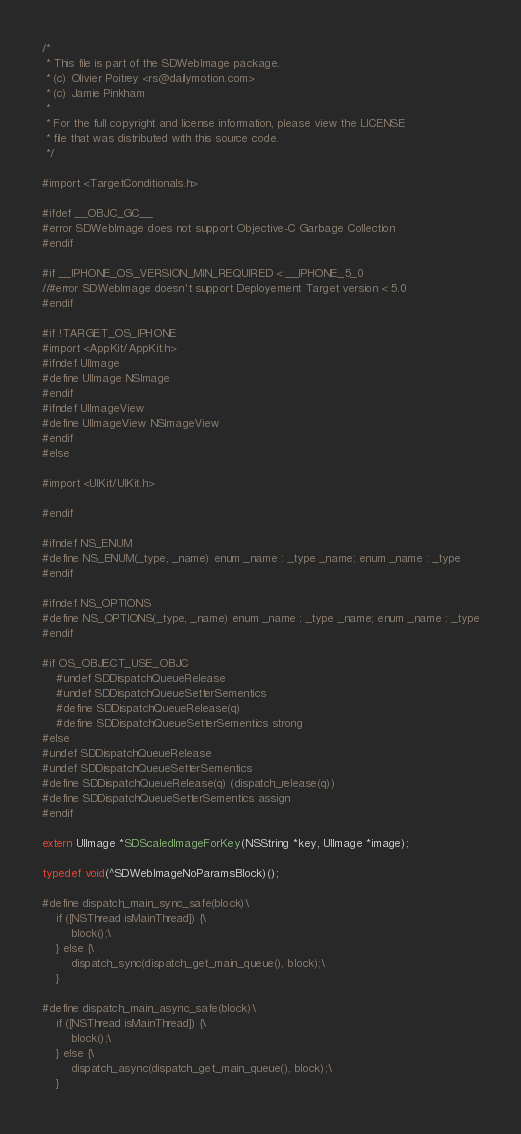<code> <loc_0><loc_0><loc_500><loc_500><_C_>/*
 * This file is part of the SDWebImage package.
 * (c) Olivier Poitrey <rs@dailymotion.com>
 * (c) Jamie Pinkham
 *
 * For the full copyright and license information, please view the LICENSE
 * file that was distributed with this source code.
 */

#import <TargetConditionals.h>

#ifdef __OBJC_GC__
#error SDWebImage does not support Objective-C Garbage Collection
#endif

#if __IPHONE_OS_VERSION_MIN_REQUIRED < __IPHONE_5_0
//#error SDWebImage doesn't support Deployement Target version < 5.0
#endif

#if !TARGET_OS_IPHONE
#import <AppKit/AppKit.h>
#ifndef UIImage
#define UIImage NSImage
#endif
#ifndef UIImageView
#define UIImageView NSImageView
#endif
#else

#import <UIKit/UIKit.h>

#endif

#ifndef NS_ENUM
#define NS_ENUM(_type, _name) enum _name : _type _name; enum _name : _type
#endif

#ifndef NS_OPTIONS
#define NS_OPTIONS(_type, _name) enum _name : _type _name; enum _name : _type
#endif

#if OS_OBJECT_USE_OBJC
    #undef SDDispatchQueueRelease
    #undef SDDispatchQueueSetterSementics
    #define SDDispatchQueueRelease(q)
    #define SDDispatchQueueSetterSementics strong
#else
#undef SDDispatchQueueRelease
#undef SDDispatchQueueSetterSementics
#define SDDispatchQueueRelease(q) (dispatch_release(q))
#define SDDispatchQueueSetterSementics assign
#endif

extern UIImage *SDScaledImageForKey(NSString *key, UIImage *image);

typedef void(^SDWebImageNoParamsBlock)();

#define dispatch_main_sync_safe(block)\
    if ([NSThread isMainThread]) {\
        block();\
    } else {\
        dispatch_sync(dispatch_get_main_queue(), block);\
    }

#define dispatch_main_async_safe(block)\
    if ([NSThread isMainThread]) {\
        block();\
    } else {\
        dispatch_async(dispatch_get_main_queue(), block);\
    }
</code> 